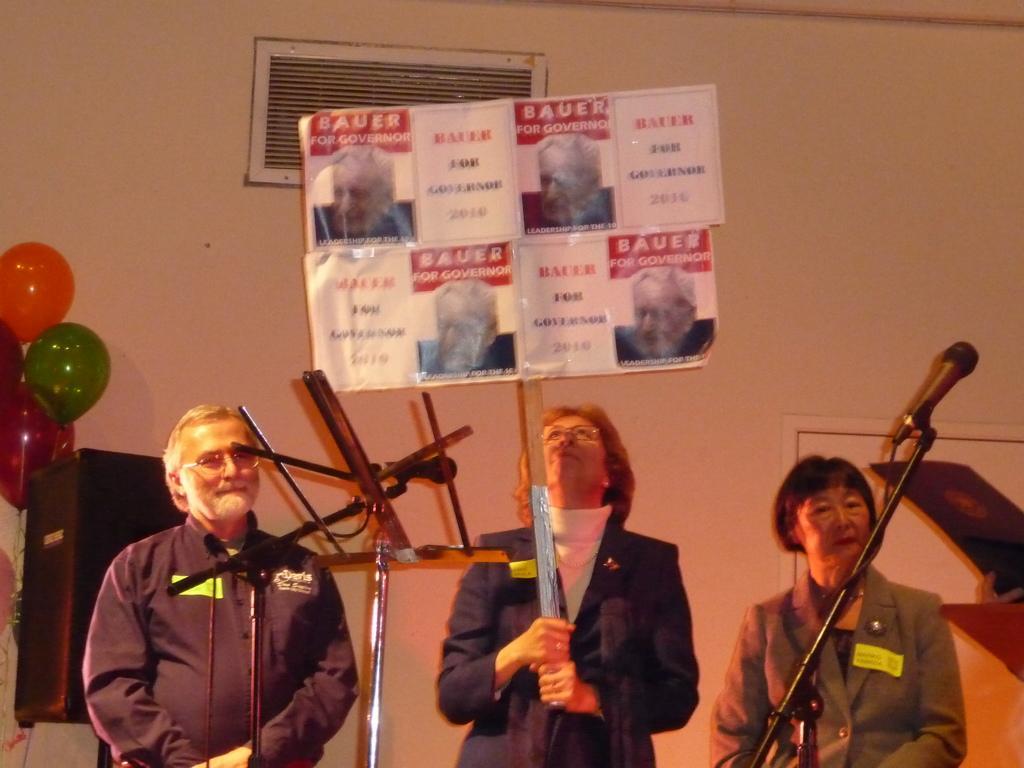In one or two sentences, can you explain what this image depicts? In this image, we can see people standing and wearing glasses and one of them is holding a board and we can see mics and stands. In the background, there is a ventilation and a wall and a door and we can see balloons and a box. 